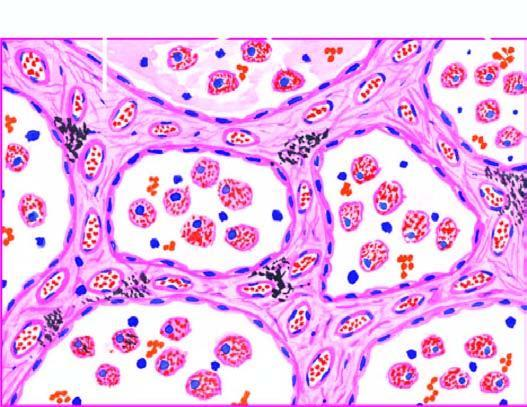do the alveolar lumina contain heart failure cells alveolar macrophages containing haemosiderin pigment?
Answer the question using a single word or phrase. Yes 